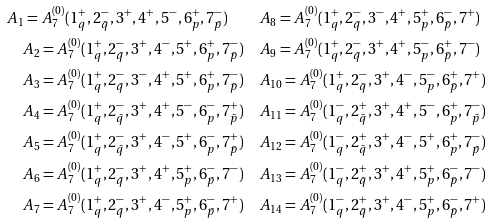<formula> <loc_0><loc_0><loc_500><loc_500>A _ { 1 } = A _ { 7 } ^ { ( 0 ) } ( 1 _ { q } ^ { + } , 2 _ { \bar { q } } ^ { - } , 3 ^ { + } , 4 ^ { + } , 5 ^ { - } , 6 _ { p } ^ { + } , 7 _ { \bar { p } } ^ { - } ) \quad & A _ { 8 } = A _ { 7 } ^ { ( 0 ) } ( 1 _ { q } ^ { + } , 2 _ { \bar { q } } ^ { - } , 3 ^ { - } , 4 ^ { + } , 5 _ { p } ^ { + } , 6 _ { \bar { p } } ^ { - } , 7 ^ { + } ) \\ A _ { 2 } = A _ { 7 } ^ { ( 0 ) } ( 1 _ { q } ^ { + } , 2 _ { \bar { q } } ^ { - } , 3 ^ { + } , 4 ^ { - } , 5 ^ { + } , 6 _ { p } ^ { + } , 7 _ { \bar { p } } ^ { - } ) \quad & A _ { 9 } = A _ { 7 } ^ { ( 0 ) } ( 1 _ { q } ^ { + } , 2 _ { \bar { q } } ^ { - } , 3 ^ { + } , 4 ^ { + } , 5 _ { p } ^ { - } , 6 _ { \bar { p } } ^ { + } , 7 ^ { - } ) \\ A _ { 3 } = A _ { 7 } ^ { ( 0 ) } ( 1 _ { q } ^ { + } , 2 _ { \bar { q } } ^ { - } , 3 ^ { - } , 4 ^ { + } , 5 ^ { + } , 6 _ { p } ^ { + } , 7 _ { \bar { p } } ^ { - } ) \quad & A _ { 1 0 } = A _ { 7 } ^ { ( 0 ) } ( 1 _ { q } ^ { + } , 2 _ { \bar { q } } ^ { - } , 3 ^ { + } , 4 ^ { - } , 5 _ { p } ^ { - } , 6 _ { \bar { p } } ^ { + } , 7 ^ { + } ) \\ A _ { 4 } = A _ { 7 } ^ { ( 0 ) } ( 1 _ { q } ^ { + } , 2 _ { \bar { q } } ^ { - } , 3 ^ { + } , 4 ^ { + } , 5 ^ { - } , 6 _ { p } ^ { - } , 7 _ { \bar { p } } ^ { + } ) \quad & A _ { 1 1 } = A _ { 7 } ^ { ( 0 ) } ( 1 _ { q } ^ { - } , 2 _ { \bar { q } } ^ { + } , 3 ^ { + } , 4 ^ { + } , 5 ^ { - } , 6 _ { p } ^ { + } , 7 _ { \bar { p } } ^ { - } ) \\ A _ { 5 } = A _ { 7 } ^ { ( 0 ) } ( 1 _ { q } ^ { + } , 2 _ { \bar { q } } ^ { - } , 3 ^ { + } , 4 ^ { - } , 5 ^ { + } , 6 _ { p } ^ { - } , 7 _ { \bar { p } } ^ { + } ) \quad & A _ { 1 2 } = A _ { 7 } ^ { ( 0 ) } ( 1 _ { q } ^ { - } , 2 _ { \bar { q } } ^ { + } , 3 ^ { + } , 4 ^ { - } , 5 ^ { + } , 6 _ { p } ^ { + } , 7 _ { \bar { p } } ^ { - } ) \\ A _ { 6 } = A _ { 7 } ^ { ( 0 ) } ( 1 _ { q } ^ { + } , 2 _ { \bar { q } } ^ { - } , 3 ^ { + } , 4 ^ { + } , 5 _ { p } ^ { + } , 6 _ { \bar { p } } ^ { - } , 7 ^ { - } ) \quad & A _ { 1 3 } = A _ { 7 } ^ { ( 0 ) } ( 1 _ { q } ^ { - } , 2 _ { \bar { q } } ^ { + } , 3 ^ { + } , 4 ^ { + } , 5 _ { p } ^ { + } , 6 _ { \bar { p } } ^ { - } , 7 ^ { - } ) \\ A _ { 7 } = A _ { 7 } ^ { ( 0 ) } ( 1 _ { q } ^ { + } , 2 _ { \bar { q } } ^ { - } , 3 ^ { + } , 4 ^ { - } , 5 _ { p } ^ { + } , 6 _ { \bar { p } } ^ { - } , 7 ^ { + } ) \quad & A _ { 1 4 } = A _ { 7 } ^ { ( 0 ) } ( 1 _ { q } ^ { - } , 2 _ { \bar { q } } ^ { + } , 3 ^ { + } , 4 ^ { - } , 5 _ { p } ^ { + } , 6 _ { \bar { p } } ^ { - } , 7 ^ { + } ) \\</formula> 